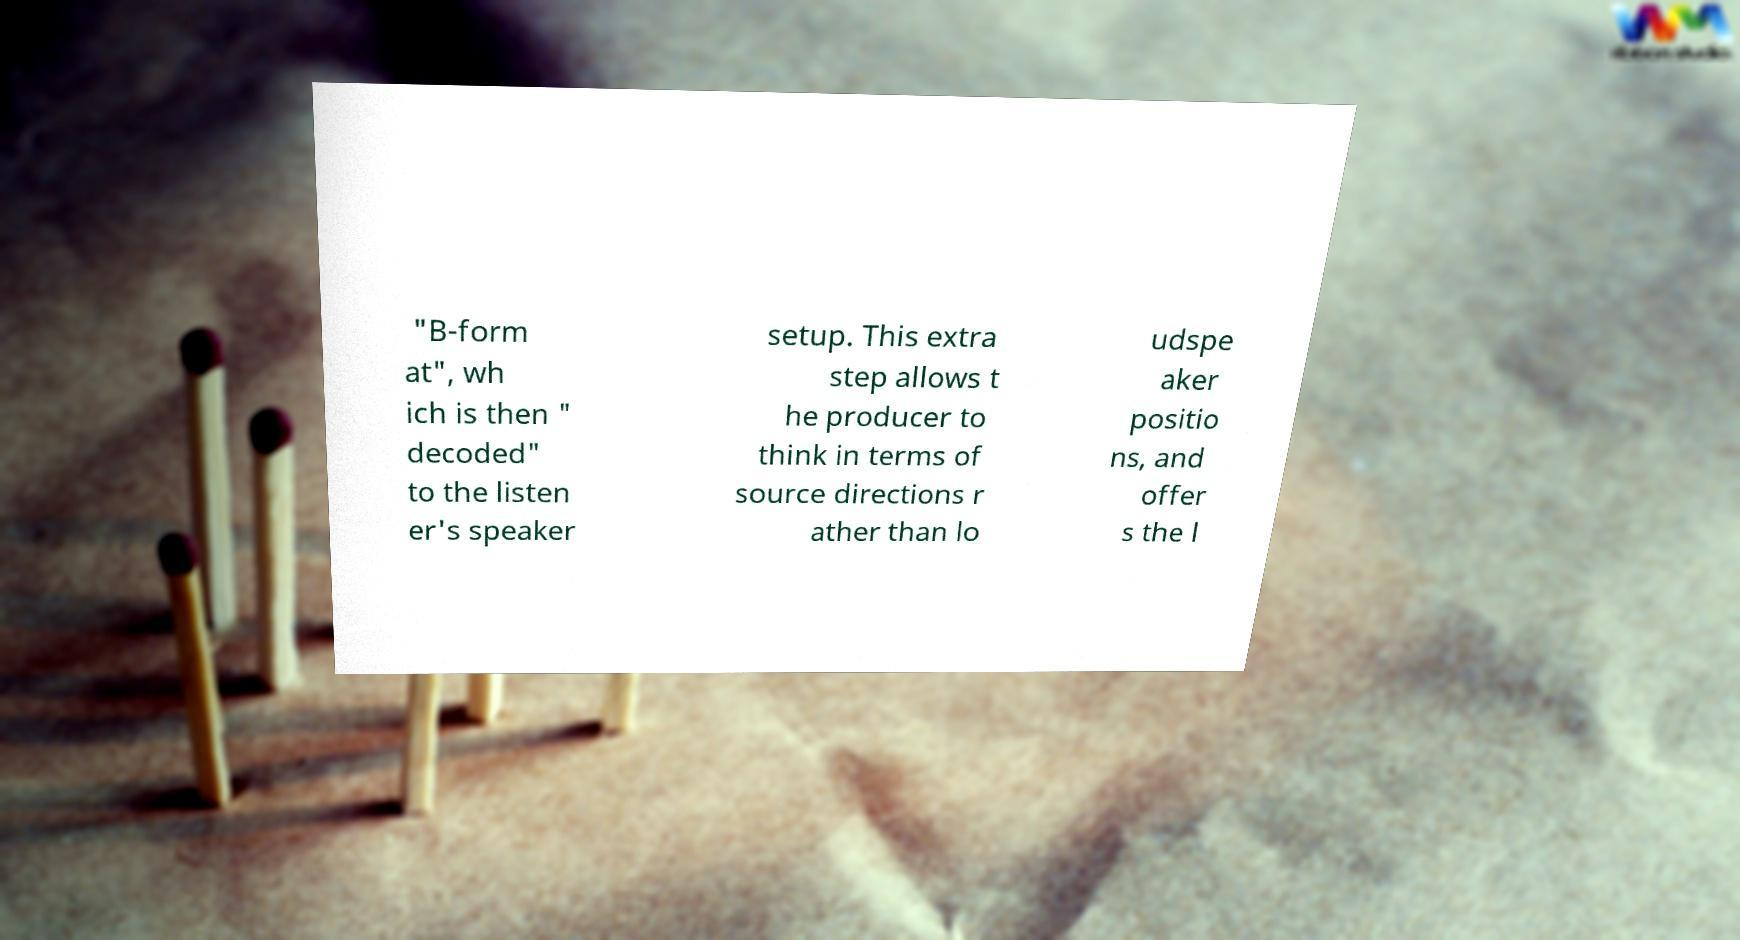Please identify and transcribe the text found in this image. "B-form at", wh ich is then " decoded" to the listen er's speaker setup. This extra step allows t he producer to think in terms of source directions r ather than lo udspe aker positio ns, and offer s the l 